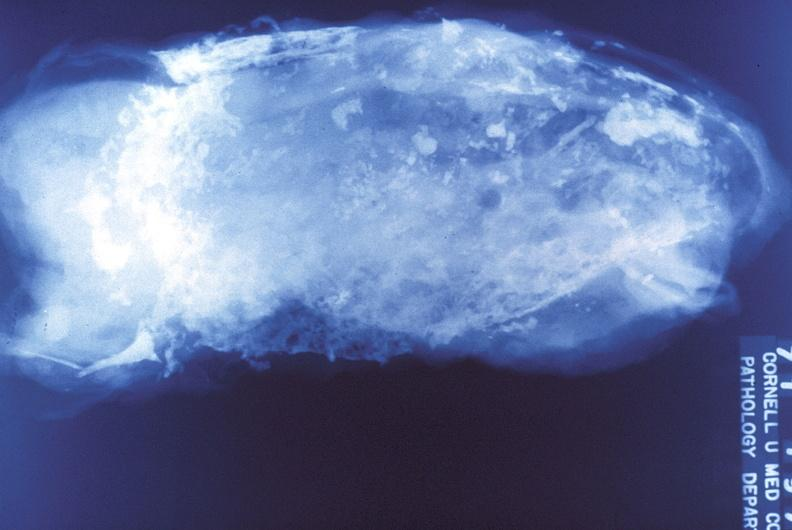what is present?
Answer the question using a single word or phrase. Respiratory 